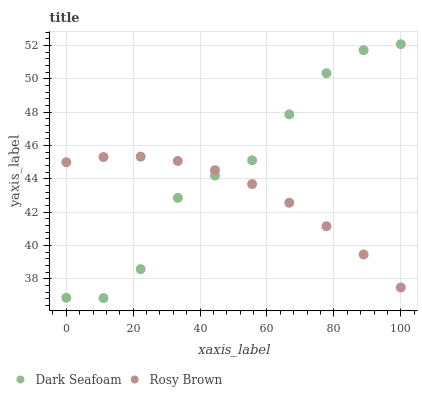Does Rosy Brown have the minimum area under the curve?
Answer yes or no. Yes. Does Dark Seafoam have the maximum area under the curve?
Answer yes or no. Yes. Does Rosy Brown have the maximum area under the curve?
Answer yes or no. No. Is Rosy Brown the smoothest?
Answer yes or no. Yes. Is Dark Seafoam the roughest?
Answer yes or no. Yes. Is Rosy Brown the roughest?
Answer yes or no. No. Does Dark Seafoam have the lowest value?
Answer yes or no. Yes. Does Rosy Brown have the lowest value?
Answer yes or no. No. Does Dark Seafoam have the highest value?
Answer yes or no. Yes. Does Rosy Brown have the highest value?
Answer yes or no. No. Does Dark Seafoam intersect Rosy Brown?
Answer yes or no. Yes. Is Dark Seafoam less than Rosy Brown?
Answer yes or no. No. Is Dark Seafoam greater than Rosy Brown?
Answer yes or no. No. 